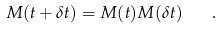<formula> <loc_0><loc_0><loc_500><loc_500>M ( t + \delta t ) = M ( t ) M ( \delta t ) \quad .</formula> 